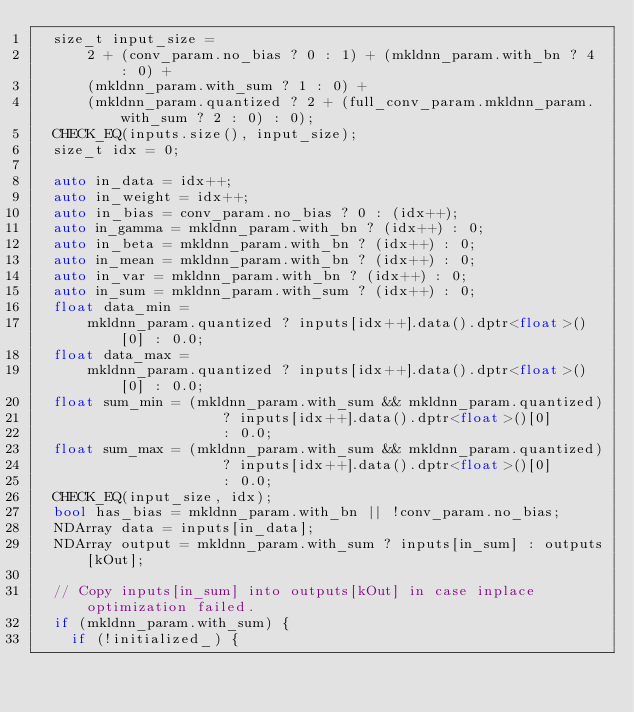Convert code to text. <code><loc_0><loc_0><loc_500><loc_500><_C++_>  size_t input_size =
      2 + (conv_param.no_bias ? 0 : 1) + (mkldnn_param.with_bn ? 4 : 0) +
      (mkldnn_param.with_sum ? 1 : 0) +
      (mkldnn_param.quantized ? 2 + (full_conv_param.mkldnn_param.with_sum ? 2 : 0) : 0);
  CHECK_EQ(inputs.size(), input_size);
  size_t idx = 0;

  auto in_data = idx++;
  auto in_weight = idx++;
  auto in_bias = conv_param.no_bias ? 0 : (idx++);
  auto in_gamma = mkldnn_param.with_bn ? (idx++) : 0;
  auto in_beta = mkldnn_param.with_bn ? (idx++) : 0;
  auto in_mean = mkldnn_param.with_bn ? (idx++) : 0;
  auto in_var = mkldnn_param.with_bn ? (idx++) : 0;
  auto in_sum = mkldnn_param.with_sum ? (idx++) : 0;
  float data_min =
      mkldnn_param.quantized ? inputs[idx++].data().dptr<float>()[0] : 0.0;
  float data_max =
      mkldnn_param.quantized ? inputs[idx++].data().dptr<float>()[0] : 0.0;
  float sum_min = (mkldnn_param.with_sum && mkldnn_param.quantized)
                      ? inputs[idx++].data().dptr<float>()[0]
                      : 0.0;
  float sum_max = (mkldnn_param.with_sum && mkldnn_param.quantized)
                      ? inputs[idx++].data().dptr<float>()[0]
                      : 0.0;
  CHECK_EQ(input_size, idx);
  bool has_bias = mkldnn_param.with_bn || !conv_param.no_bias;
  NDArray data = inputs[in_data];
  NDArray output = mkldnn_param.with_sum ? inputs[in_sum] : outputs[kOut];

  // Copy inputs[in_sum] into outputs[kOut] in case inplace optimization failed.
  if (mkldnn_param.with_sum) {
    if (!initialized_) {</code> 